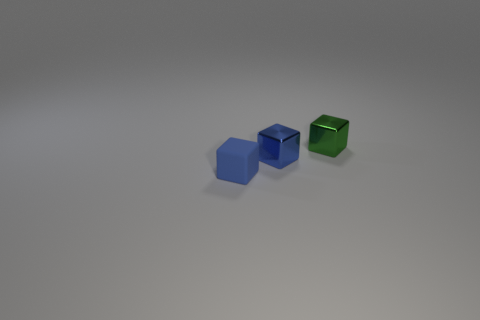Add 3 tiny red cylinders. How many objects exist? 6 Add 3 small blue metal objects. How many small blue metal objects are left? 4 Add 1 small blue shiny cubes. How many small blue shiny cubes exist? 2 Subtract 0 green cylinders. How many objects are left? 3 Subtract all cyan shiny blocks. Subtract all tiny green things. How many objects are left? 2 